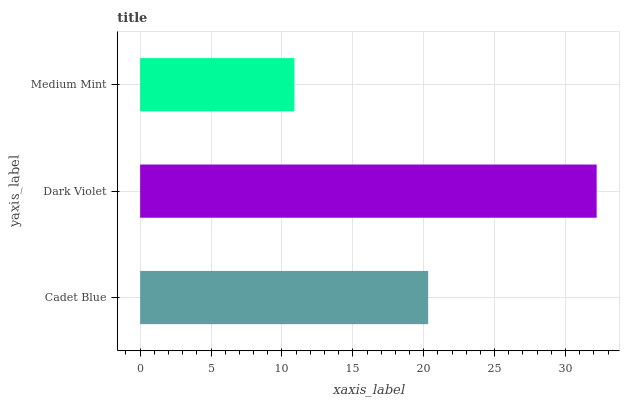Is Medium Mint the minimum?
Answer yes or no. Yes. Is Dark Violet the maximum?
Answer yes or no. Yes. Is Dark Violet the minimum?
Answer yes or no. No. Is Medium Mint the maximum?
Answer yes or no. No. Is Dark Violet greater than Medium Mint?
Answer yes or no. Yes. Is Medium Mint less than Dark Violet?
Answer yes or no. Yes. Is Medium Mint greater than Dark Violet?
Answer yes or no. No. Is Dark Violet less than Medium Mint?
Answer yes or no. No. Is Cadet Blue the high median?
Answer yes or no. Yes. Is Cadet Blue the low median?
Answer yes or no. Yes. Is Dark Violet the high median?
Answer yes or no. No. Is Medium Mint the low median?
Answer yes or no. No. 